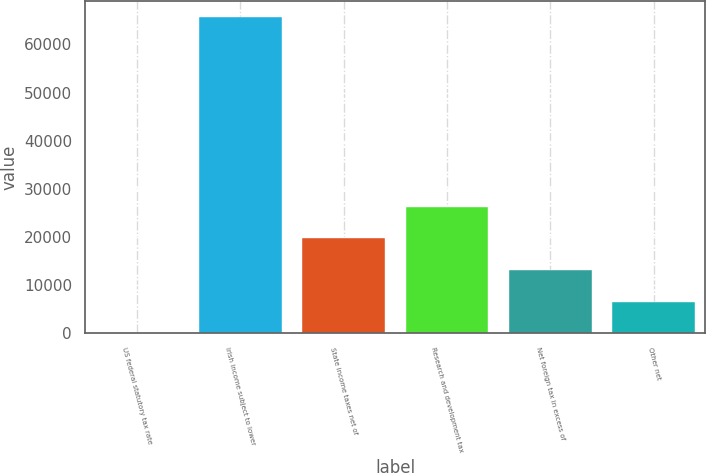Convert chart to OTSL. <chart><loc_0><loc_0><loc_500><loc_500><bar_chart><fcel>US federal statutory tax rate<fcel>Irish income subject to lower<fcel>State income taxes net of<fcel>Research and development tax<fcel>Net foreign tax in excess of<fcel>Other net<nl><fcel>35<fcel>65673<fcel>19726.4<fcel>26290.2<fcel>13162.6<fcel>6598.8<nl></chart> 